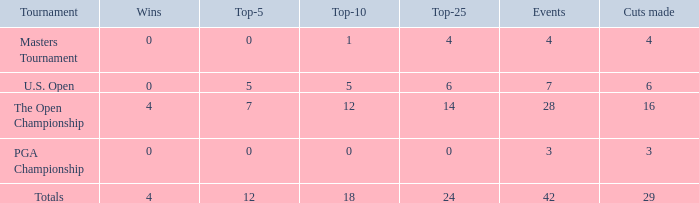Can you give me this table as a dict? {'header': ['Tournament', 'Wins', 'Top-5', 'Top-10', 'Top-25', 'Events', 'Cuts made'], 'rows': [['Masters Tournament', '0', '0', '1', '4', '4', '4'], ['U.S. Open', '0', '5', '5', '6', '7', '6'], ['The Open Championship', '4', '7', '12', '14', '28', '16'], ['PGA Championship', '0', '0', '0', '0', '3', '3'], ['Totals', '4', '12', '18', '24', '42', '29']]} What are the lowest top-5 with a top-25 larger than 4, 29 cuts and a top-10 larger than 18? None. 